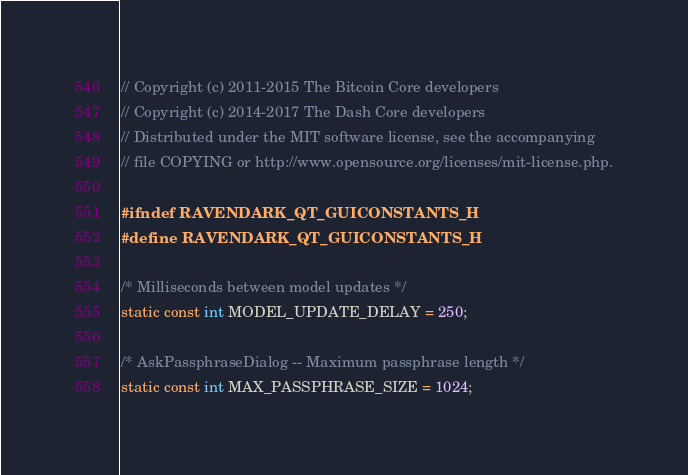Convert code to text. <code><loc_0><loc_0><loc_500><loc_500><_C_>// Copyright (c) 2011-2015 The Bitcoin Core developers
// Copyright (c) 2014-2017 The Dash Core developers
// Distributed under the MIT software license, see the accompanying
// file COPYING or http://www.opensource.org/licenses/mit-license.php.

#ifndef RAVENDARK_QT_GUICONSTANTS_H
#define RAVENDARK_QT_GUICONSTANTS_H

/* Milliseconds between model updates */
static const int MODEL_UPDATE_DELAY = 250;

/* AskPassphraseDialog -- Maximum passphrase length */
static const int MAX_PASSPHRASE_SIZE = 1024;
</code> 